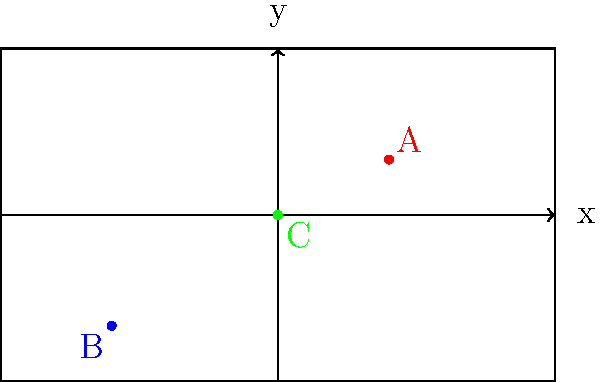As a sports team manager, you're analyzing player positioning on the field. Using the coordinate system shown, where the x-axis represents the width of the field and the y-axis represents the length, determine the coordinates of player B. What is the total distance between players A and B? To solve this problem, we'll follow these steps:

1. Identify the coordinates of players A and B:
   Player A: $(2, 1)$
   Player B: $(-3, -2)$

2. Calculate the distance between A and B using the distance formula:
   $d = \sqrt{(x_2 - x_1)^2 + (y_2 - y_1)^2}$

3. Substitute the values:
   $d = \sqrt{(-3 - 2)^2 + (-2 - 1)^2}$

4. Simplify:
   $d = \sqrt{(-5)^2 + (-3)^2}$
   $d = \sqrt{25 + 9}$
   $d = \sqrt{34}$

5. Simplify the square root:
   $d = \sqrt{34} \approx 5.83$

Therefore, the coordinates of player B are $(-3, -2)$, and the total distance between players A and B is approximately 5.83 units.
Answer: Coordinates of B: $(-3, -2)$; Distance: $\sqrt{34}$ units 